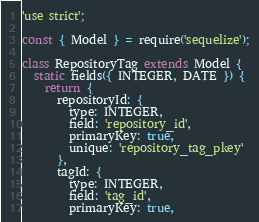<code> <loc_0><loc_0><loc_500><loc_500><_JavaScript_>'use strict';

const { Model } = require('sequelize');

class RepositoryTag extends Model {
  static fields({ INTEGER, DATE }) {
    return {
      repositoryId: {
        type: INTEGER,
        field: 'repository_id',
        primaryKey: true,
        unique: 'repository_tag_pkey'
      },
      tagId: {
        type: INTEGER,
        field: 'tag_id',
        primaryKey: true,</code> 